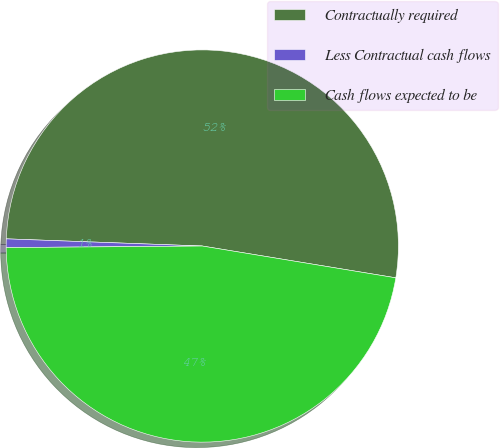Convert chart to OTSL. <chart><loc_0><loc_0><loc_500><loc_500><pie_chart><fcel>Contractually required<fcel>Less Contractual cash flows<fcel>Cash flows expected to be<nl><fcel>52.01%<fcel>0.71%<fcel>47.28%<nl></chart> 